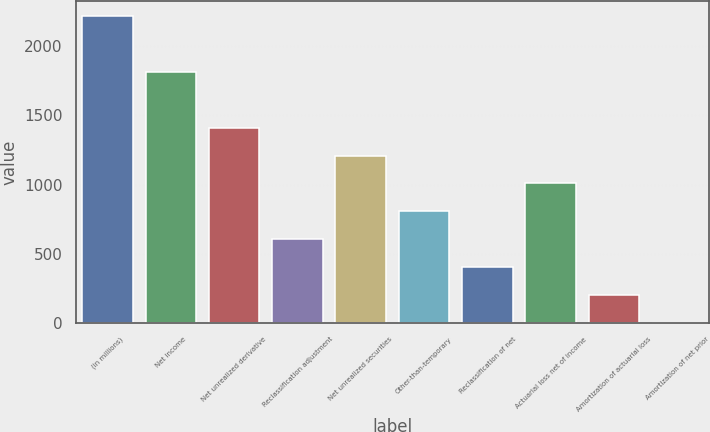<chart> <loc_0><loc_0><loc_500><loc_500><bar_chart><fcel>(in millions)<fcel>Net income<fcel>Net unrealized derivative<fcel>Reclassification adjustment<fcel>Net unrealized securities<fcel>Other-than-temporary<fcel>Reclassification of net<fcel>Actuarial loss net of income<fcel>Amortization of actuarial loss<fcel>Amortization of net prior<nl><fcel>2215.3<fcel>1812.7<fcel>1410.1<fcel>604.9<fcel>1208.8<fcel>806.2<fcel>403.6<fcel>1007.5<fcel>202.3<fcel>1<nl></chart> 